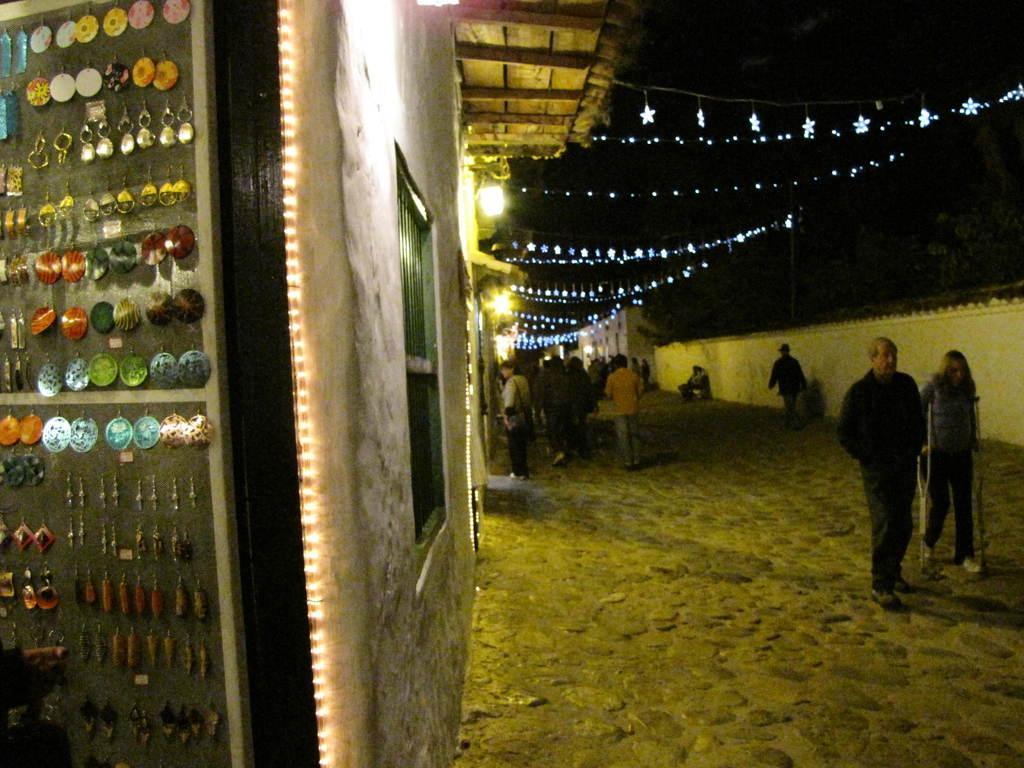Describe this image in one or two sentences. In the image I can see people on the ground. In the background I can see string lights, lights, houses and wall fence. On the left side of the image I can see some objects attached to the board. 